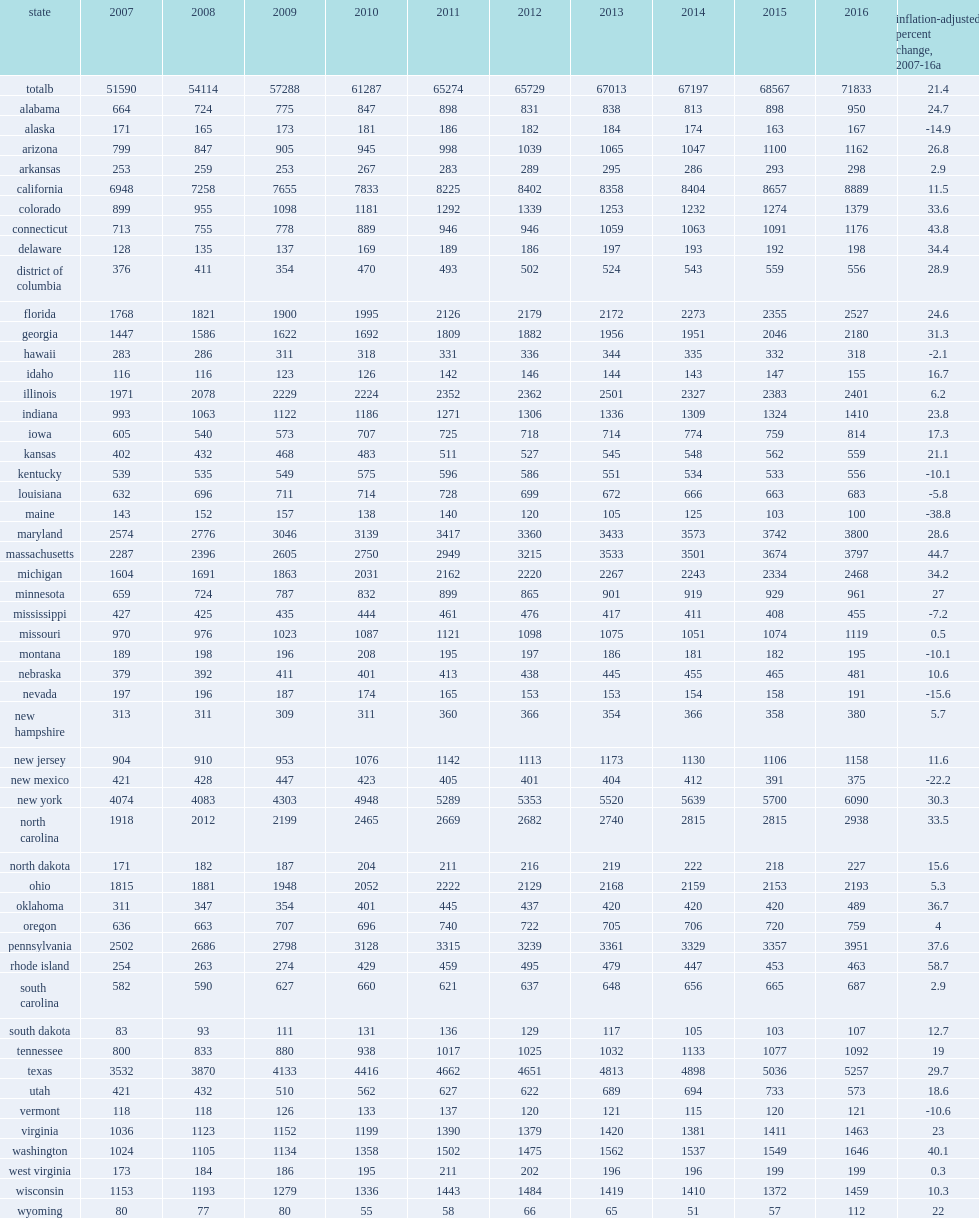How many million dollars did universities in each of these states spend 5% or more on? 71833.0. Give me the full table as a dictionary. {'header': ['state', '2007', '2008', '2009', '2010', '2011', '2012', '2013', '2014', '2015', '2016', 'inflation-adjusted percent change, 2007-16a'], 'rows': [['totalb', '51590', '54114', '57288', '61287', '65274', '65729', '67013', '67197', '68567', '71833', '21.4'], ['alabama', '664', '724', '775', '847', '898', '831', '838', '813', '898', '950', '24.7'], ['alaska', '171', '165', '173', '181', '186', '182', '184', '174', '163', '167', '-14.9'], ['arizona', '799', '847', '905', '945', '998', '1039', '1065', '1047', '1100', '1162', '26.8'], ['arkansas', '253', '259', '253', '267', '283', '289', '295', '286', '293', '298', '2.9'], ['california', '6948', '7258', '7655', '7833', '8225', '8402', '8358', '8404', '8657', '8889', '11.5'], ['colorado', '899', '955', '1098', '1181', '1292', '1339', '1253', '1232', '1274', '1379', '33.6'], ['connecticut', '713', '755', '778', '889', '946', '946', '1059', '1063', '1091', '1176', '43.8'], ['delaware', '128', '135', '137', '169', '189', '186', '197', '193', '192', '198', '34.4'], ['district of columbia', '376', '411', '354', '470', '493', '502', '524', '543', '559', '556', '28.9'], ['florida', '1768', '1821', '1900', '1995', '2126', '2179', '2172', '2273', '2355', '2527', '24.6'], ['georgia', '1447', '1586', '1622', '1692', '1809', '1882', '1956', '1951', '2046', '2180', '31.3'], ['hawaii', '283', '286', '311', '318', '331', '336', '344', '335', '332', '318', '-2.1'], ['idaho', '116', '116', '123', '126', '142', '146', '144', '143', '147', '155', '16.7'], ['illinois', '1971', '2078', '2229', '2224', '2352', '2362', '2501', '2327', '2383', '2401', '6.2'], ['indiana', '993', '1063', '1122', '1186', '1271', '1306', '1336', '1309', '1324', '1410', '23.8'], ['iowa', '605', '540', '573', '707', '725', '718', '714', '774', '759', '814', '17.3'], ['kansas', '402', '432', '468', '483', '511', '527', '545', '548', '562', '559', '21.1'], ['kentucky', '539', '535', '549', '575', '596', '586', '551', '534', '533', '556', '-10.1'], ['louisiana', '632', '696', '711', '714', '728', '699', '672', '666', '663', '683', '-5.8'], ['maine', '143', '152', '157', '138', '140', '120', '105', '125', '103', '100', '-38.8'], ['maryland', '2574', '2776', '3046', '3139', '3417', '3360', '3433', '3573', '3742', '3800', '28.6'], ['massachusetts', '2287', '2396', '2605', '2750', '2949', '3215', '3533', '3501', '3674', '3797', '44.7'], ['michigan', '1604', '1691', '1863', '2031', '2162', '2220', '2267', '2243', '2334', '2468', '34.2'], ['minnesota', '659', '724', '787', '832', '899', '865', '901', '919', '929', '961', '27'], ['mississippi', '427', '425', '435', '444', '461', '476', '417', '411', '408', '455', '-7.2'], ['missouri', '970', '976', '1023', '1087', '1121', '1098', '1075', '1051', '1074', '1119', '0.5'], ['montana', '189', '198', '196', '208', '195', '197', '186', '181', '182', '195', '-10.1'], ['nebraska', '379', '392', '411', '401', '413', '438', '445', '455', '465', '481', '10.6'], ['nevada', '197', '196', '187', '174', '165', '153', '153', '154', '158', '191', '-15.6'], ['new hampshire', '313', '311', '309', '311', '360', '366', '354', '366', '358', '380', '5.7'], ['new jersey', '904', '910', '953', '1076', '1142', '1113', '1173', '1130', '1106', '1158', '11.6'], ['new mexico', '421', '428', '447', '423', '405', '401', '404', '412', '391', '375', '-22.2'], ['new york', '4074', '4083', '4303', '4948', '5289', '5353', '5520', '5639', '5700', '6090', '30.3'], ['north carolina', '1918', '2012', '2199', '2465', '2669', '2682', '2740', '2815', '2815', '2938', '33.5'], ['north dakota', '171', '182', '187', '204', '211', '216', '219', '222', '218', '227', '15.6'], ['ohio', '1815', '1881', '1948', '2052', '2222', '2129', '2168', '2159', '2153', '2193', '5.3'], ['oklahoma', '311', '347', '354', '401', '445', '437', '420', '420', '420', '489', '36.7'], ['oregon', '636', '663', '707', '696', '740', '722', '705', '706', '720', '759', '4'], ['pennsylvania', '2502', '2686', '2798', '3128', '3315', '3239', '3361', '3329', '3357', '3951', '37.6'], ['rhode island', '254', '263', '274', '429', '459', '495', '479', '447', '453', '463', '58.7'], ['south carolina', '582', '590', '627', '660', '621', '637', '648', '656', '665', '687', '2.9'], ['south dakota', '83', '93', '111', '131', '136', '129', '117', '105', '103', '107', '12.7'], ['tennessee', '800', '833', '880', '938', '1017', '1025', '1032', '1133', '1077', '1092', '19'], ['texas', '3532', '3870', '4133', '4416', '4662', '4651', '4813', '4898', '5036', '5257', '29.7'], ['utah', '421', '432', '510', '562', '627', '622', '689', '694', '733', '573', '18.6'], ['vermont', '118', '118', '126', '133', '137', '120', '121', '115', '120', '121', '-10.6'], ['virginia', '1036', '1123', '1152', '1199', '1390', '1379', '1420', '1381', '1411', '1463', '23'], ['washington', '1024', '1105', '1134', '1358', '1502', '1475', '1562', '1537', '1549', '1646', '40.1'], ['west virginia', '173', '184', '186', '195', '211', '202', '196', '196', '199', '199', '0.3'], ['wisconsin', '1153', '1193', '1279', '1336', '1443', '1484', '1419', '1410', '1372', '1459', '10.3'], ['wyoming', '80', '77', '80', '55', '58', '66', '65', '51', '57', '112', '22']]} 